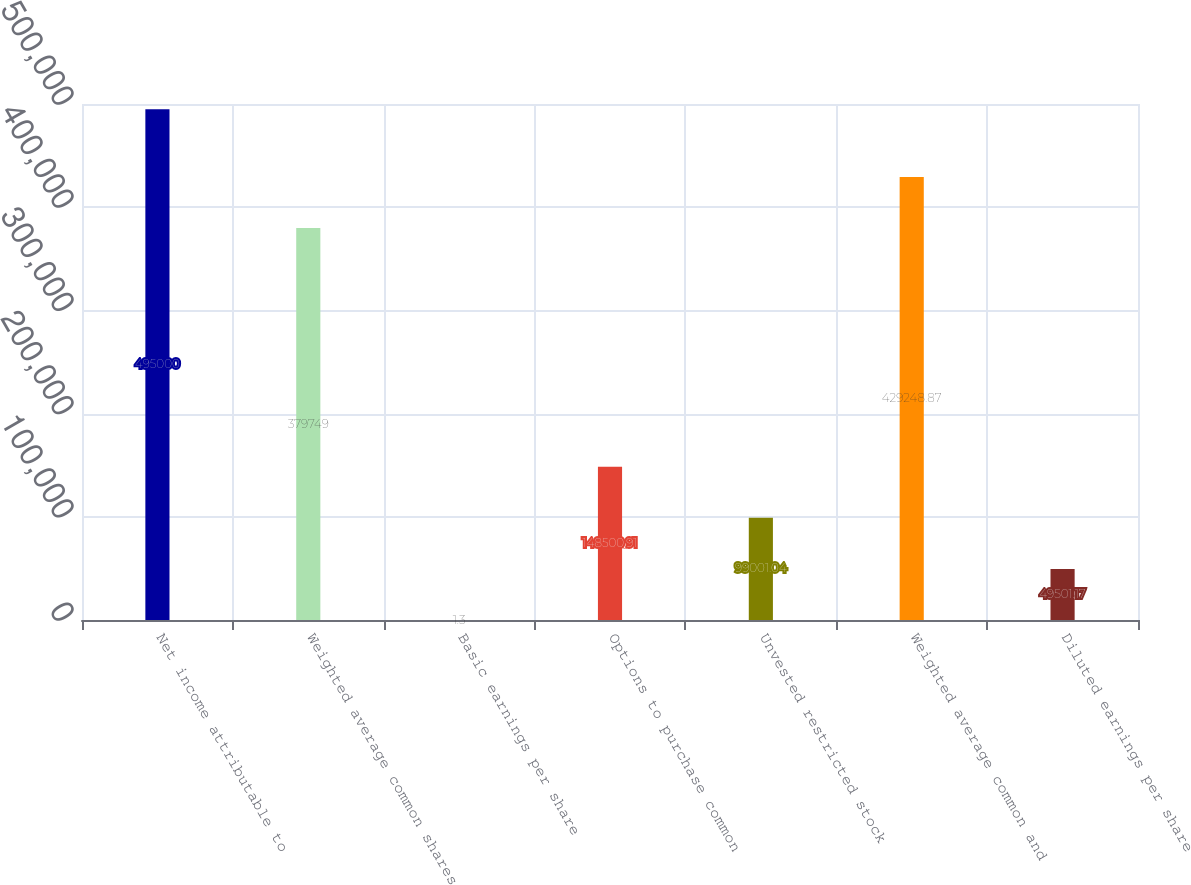Convert chart to OTSL. <chart><loc_0><loc_0><loc_500><loc_500><bar_chart><fcel>Net income attributable to<fcel>Weighted average common shares<fcel>Basic earnings per share<fcel>Options to purchase common<fcel>Unvested restricted stock<fcel>Weighted average common and<fcel>Diluted earnings per share<nl><fcel>495000<fcel>379749<fcel>1.3<fcel>148501<fcel>99001<fcel>429249<fcel>49501.2<nl></chart> 